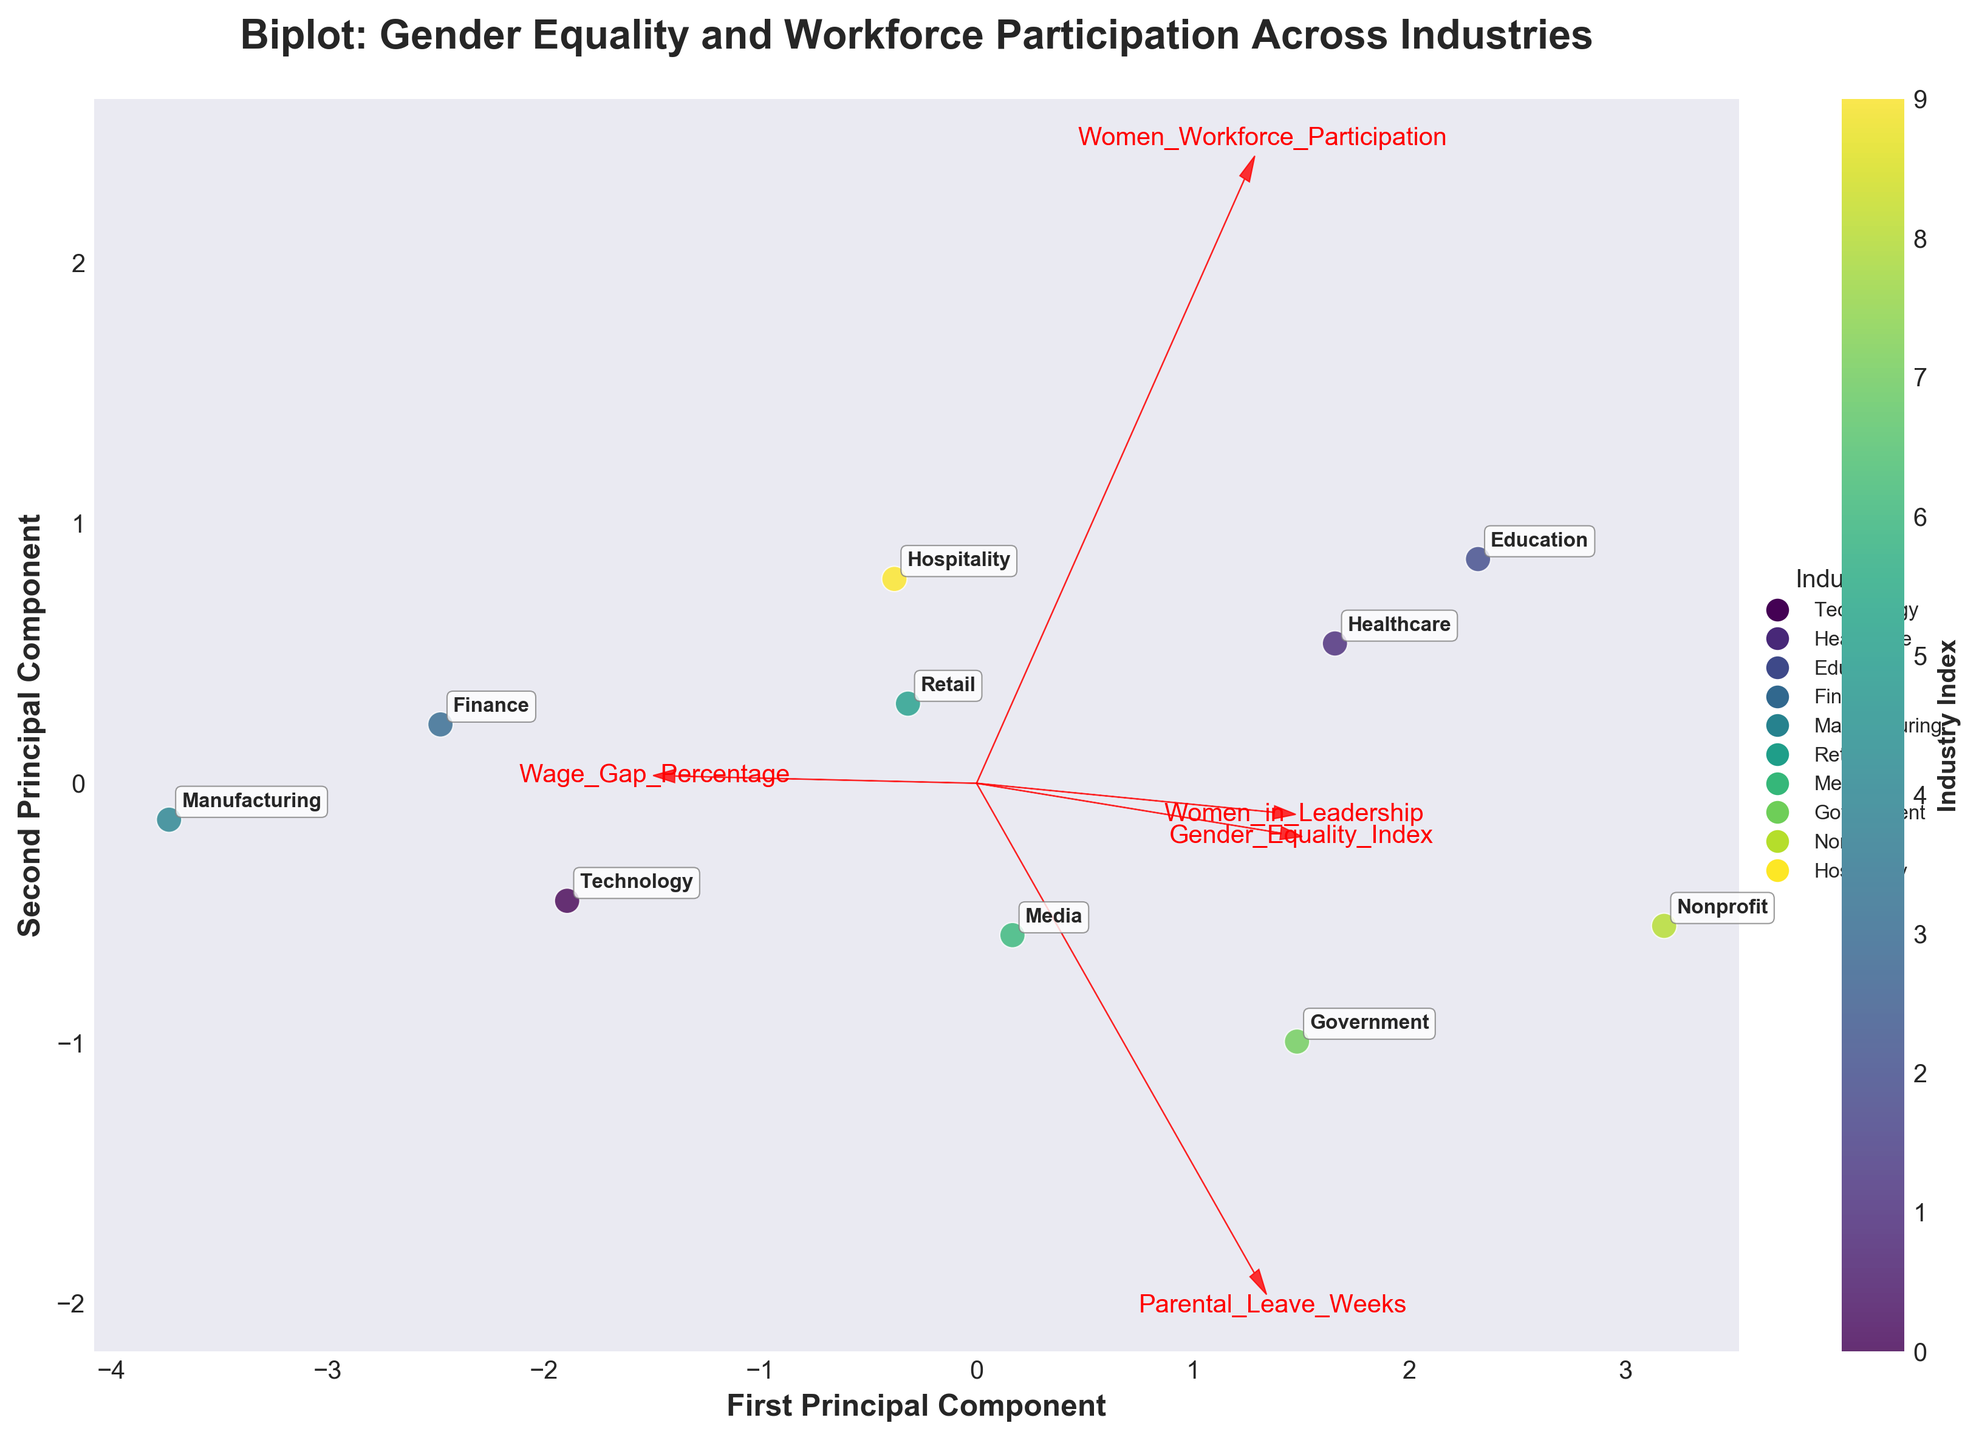What is the title of the figure? The title is located at the top of the figure. It summarizes what the plot is about. Here, the title reads "Biplot: Gender Equality and Workforce Participation Across Industries."
Answer: Biplot: Gender Equality and Workforce Participation Across Industries How many principal components are displayed on the axes? The x-axis and y-axis labels indicate two principal components: 'First Principal Component' and 'Second Principal Component.'
Answer: Two Which industry has the highest value for 'Women Workforce Participation'? From the annotations in the plot, the 'Healthcare' industry appears farthest along the direction of the 'Women Workforce Participation' vector, indicating the highest value.
Answer: Healthcare In which quadrant does the 'Technology' industry lie? 'Technology' can be found in the bottom-left quadrant because its coordinates on the plot are negative for both principal components.
Answer: Bottom-left Compare 'Retail' and 'Finance' based on their position on the plot. Which industry has a higher value on the 'Gender Equality Index'? The position of 'Retail' is closer to the vector for 'Gender Equality Index' than 'Finance,' indicating a higher value.
Answer: Retail Which feature has the longest vector and thus the greatest influence on the first two principal components? By comparing the lengths of the red vectors emanating from the origin, 'Women Workforce Participation' appears to have the longest vector.
Answer: Women Workforce Participation Calculate the average Women Workforce Participation for 'Education' and 'Nonprofit' industries. 'Education' has a participation of 76, and 'Nonprofit' has 68. The average is calculated as (76 + 68) / 2 = 72.
Answer: 72 What feature is positively correlated with 'Parental Leave Weeks'? By observing the directions of vectors, 'Women in Leadership' points in a similar direction to 'Parental Leave Weeks,' indicating a positive correlation.
Answer: Women in Leadership Which industry has the least representation in 'Women in Leadership'? The 'Manufacturing' industry's position relative to the 'Women in Leadership' vector indicates the lowest value.
Answer: Manufacturing How does the 'Wage Gap Percentage' vector relate to the different industries? The 'Wage Gap Percentage' vector points in a direction that indicates it is inversely correlated with 'Healthcare' and 'Education,' and positively correlated with 'Manufacturing' and 'Finance.'
Answer: Inversely correlated with Healthcare and Education, positively correlated with Manufacturing and Finance 